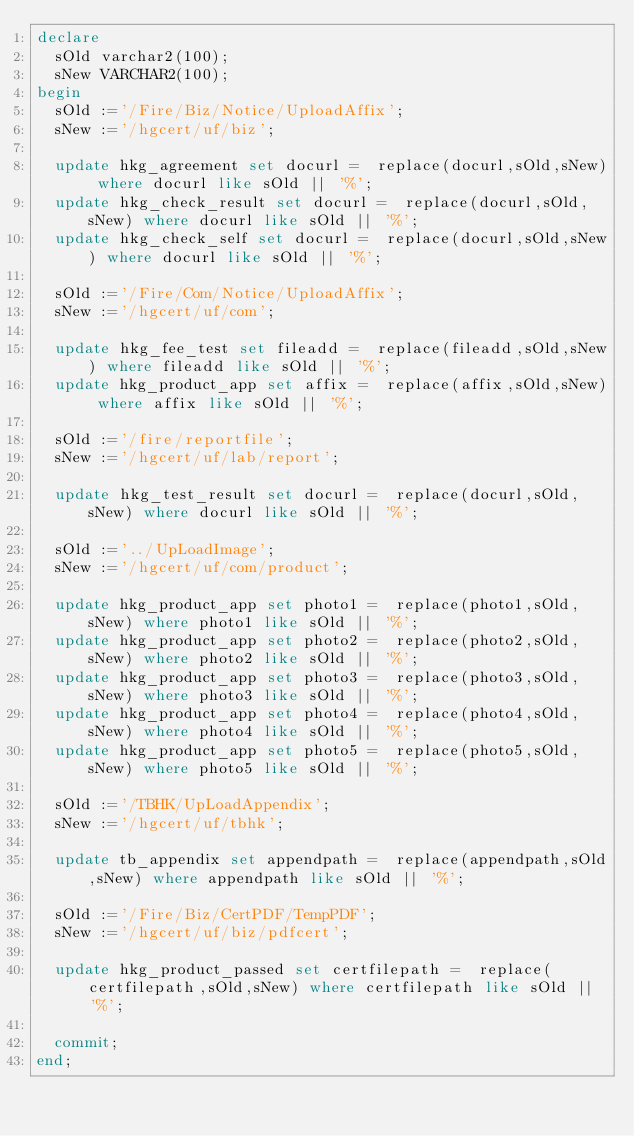<code> <loc_0><loc_0><loc_500><loc_500><_SQL_>declare 
  sOld varchar2(100);
  sNew VARCHAR2(100);
begin
  sOld :='/Fire/Biz/Notice/UploadAffix';
  sNew :='/hgcert/uf/biz';
  
  update hkg_agreement set docurl =  replace(docurl,sOld,sNew) where docurl like sOld || '%';
  update hkg_check_result set docurl =  replace(docurl,sOld,sNew) where docurl like sOld || '%';
  update hkg_check_self set docurl =  replace(docurl,sOld,sNew) where docurl like sOld || '%';

  sOld :='/Fire/Com/Notice/UploadAffix';
  sNew :='/hgcert/uf/com';
  
  update hkg_fee_test set fileadd =  replace(fileadd,sOld,sNew) where fileadd like sOld || '%';
  update hkg_product_app set affix =  replace(affix,sOld,sNew) where affix like sOld || '%';
  
  sOld :='/fire/reportfile';
  sNew :='/hgcert/uf/lab/report';
  
  update hkg_test_result set docurl =  replace(docurl,sOld,sNew) where docurl like sOld || '%';

  sOld :='../UpLoadImage';
  sNew :='/hgcert/uf/com/product';
  
  update hkg_product_app set photo1 =  replace(photo1,sOld,sNew) where photo1 like sOld || '%';
  update hkg_product_app set photo2 =  replace(photo2,sOld,sNew) where photo2 like sOld || '%';
  update hkg_product_app set photo3 =  replace(photo3,sOld,sNew) where photo3 like sOld || '%';
  update hkg_product_app set photo4 =  replace(photo4,sOld,sNew) where photo4 like sOld || '%';
  update hkg_product_app set photo5 =  replace(photo5,sOld,sNew) where photo5 like sOld || '%';

  sOld :='/TBHK/UpLoadAppendix';
  sNew :='/hgcert/uf/tbhk';
  
  update tb_appendix set appendpath =  replace(appendpath,sOld,sNew) where appendpath like sOld || '%';

  sOld :='/Fire/Biz/CertPDF/TempPDF';
  sNew :='/hgcert/uf/biz/pdfcert';
  
  update hkg_product_passed set certfilepath =  replace(certfilepath,sOld,sNew) where certfilepath like sOld || '%';
  
  commit;
end;

</code> 